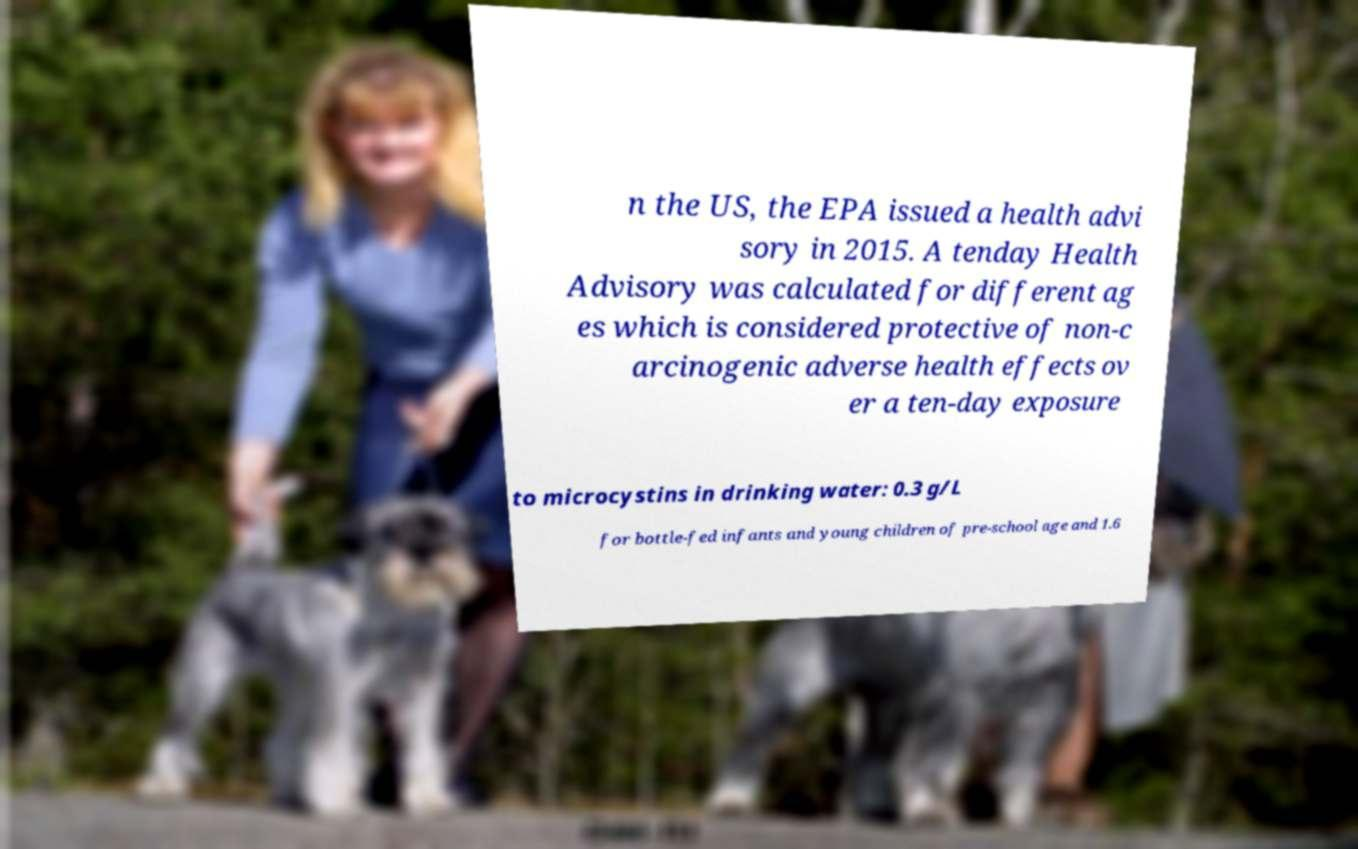Please read and relay the text visible in this image. What does it say? n the US, the EPA issued a health advi sory in 2015. A tenday Health Advisory was calculated for different ag es which is considered protective of non-c arcinogenic adverse health effects ov er a ten-day exposure to microcystins in drinking water: 0.3 g/L for bottle-fed infants and young children of pre-school age and 1.6 